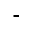<formula> <loc_0><loc_0><loc_500><loc_500>-</formula> 